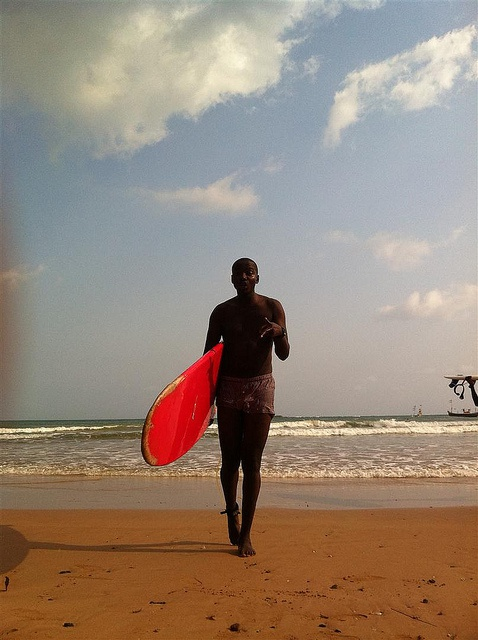Describe the objects in this image and their specific colors. I can see people in gray, black, maroon, and darkgray tones, surfboard in gray, red, brown, and maroon tones, boat in gray, black, and darkgray tones, boat in gray, darkgray, and tan tones, and boat in gray and darkgray tones in this image. 